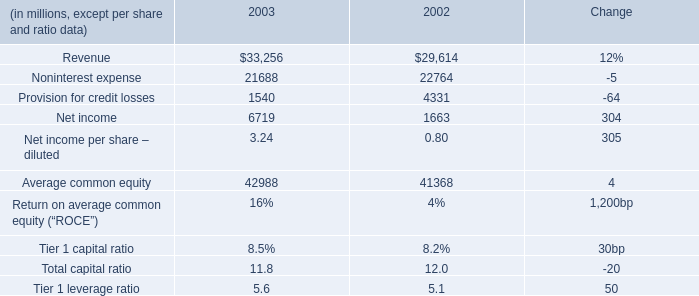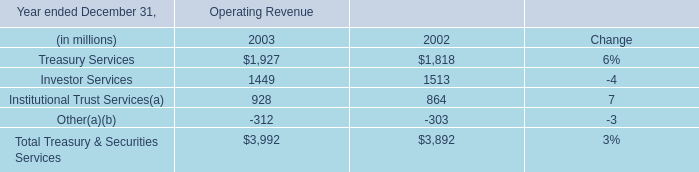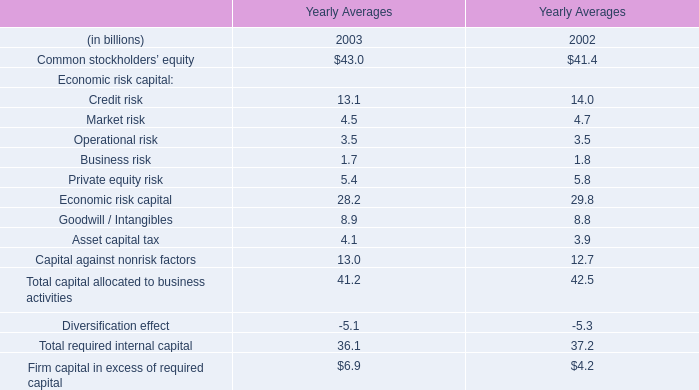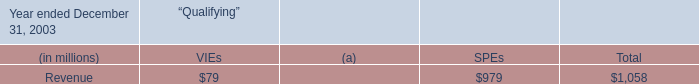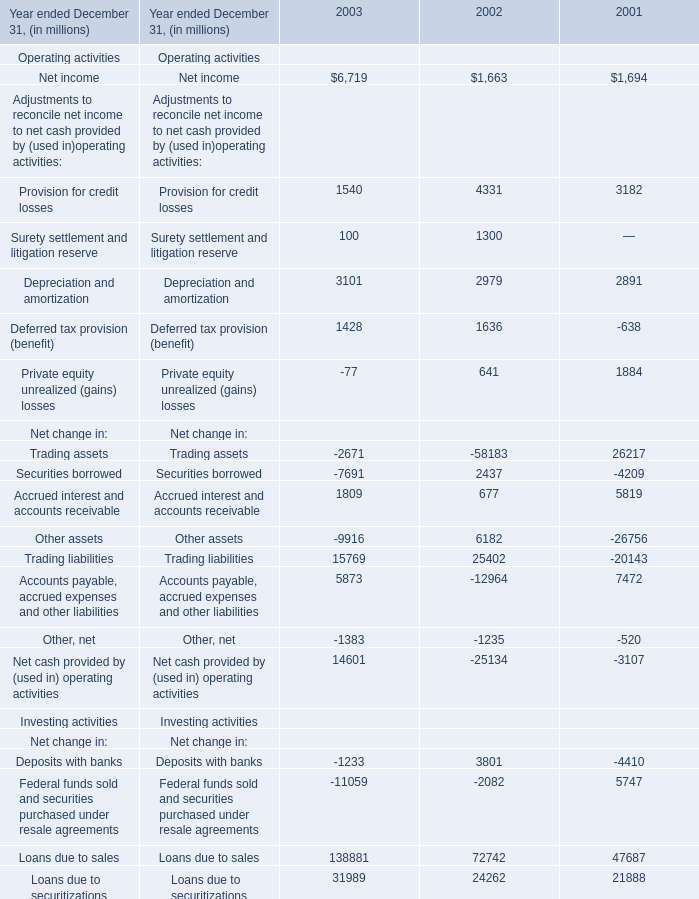What's the sum of Trading assets of 2003, and Provision for credit losses of 2003 ? 
Computations: (2671.0 + 1540.0)
Answer: 4211.0. 